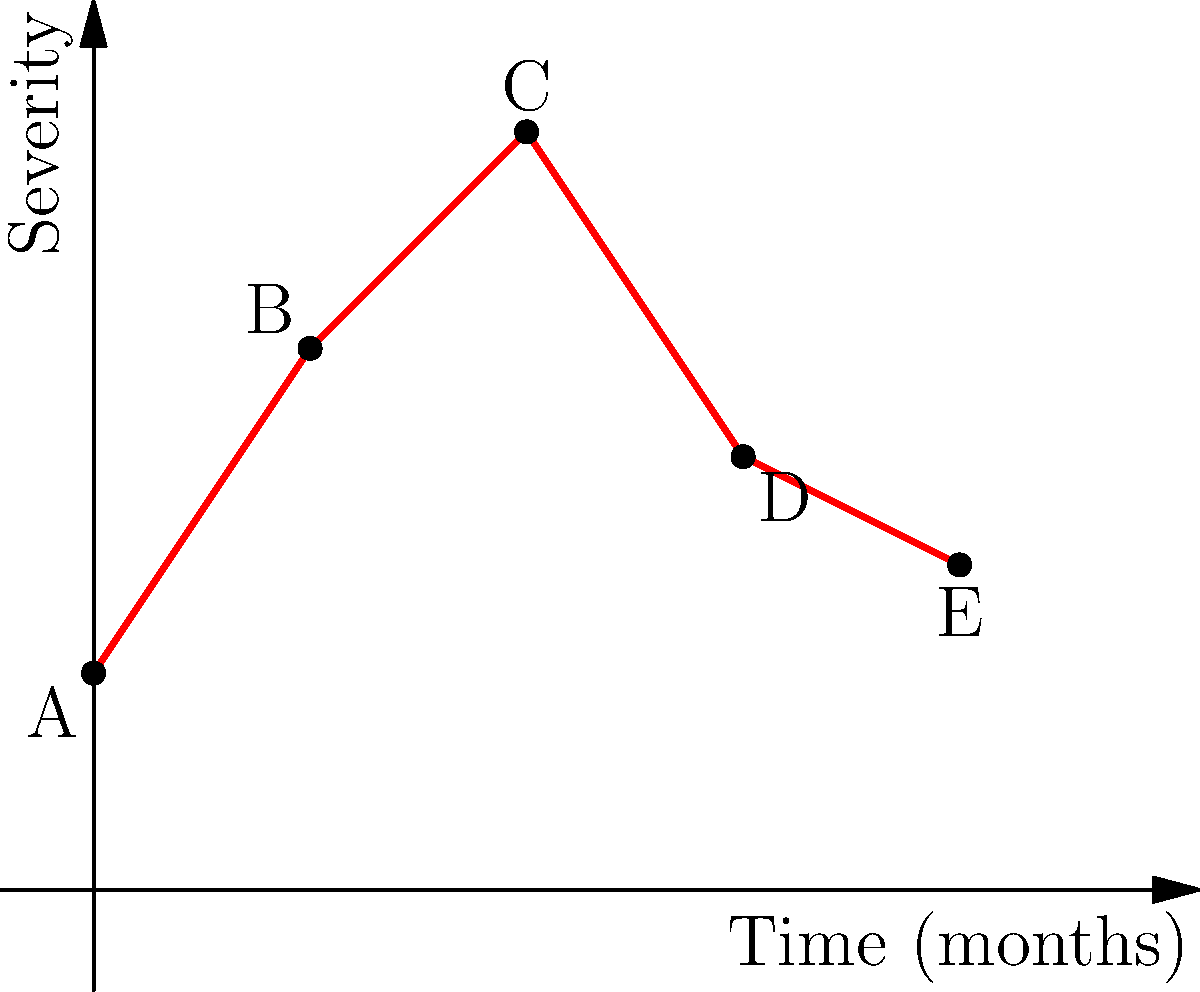The graph represents the progression of an autoimmune skin disorder over time, with each point (A-E) corresponding to a skin surface image. Based on the severity curve, at which point would you expect to observe the most extensive skin involvement and inflammation? To determine the point of most extensive skin involvement and inflammation, we need to analyze the severity curve:

1. The x-axis represents time in months, while the y-axis represents the severity of the skin disorder.
2. Each point (A-E) corresponds to a different time point and severity level.
3. We need to identify the highest point on the severity curve, which indicates the most severe symptoms.

Analyzing the points:
A (0, 1): Initial presentation, low severity
B (1, 2.5): Increasing severity
C (2, 3.5): Highest point on the curve
D (3, 2): Decreasing severity
E (4, 1.5): Further decrease in severity

The curve reaches its peak at point C, which occurs at 2 months and has the highest severity level of 3.5.

This peak indicates the time when the autoimmune skin disorder is at its most severe, likely showing the most extensive skin involvement and inflammation. At this point, we would expect to see the most pronounced clinical manifestations of the disorder, such as widespread rash, erythema, or other characteristic skin lesions associated with the specific autoimmune condition.
Answer: C 